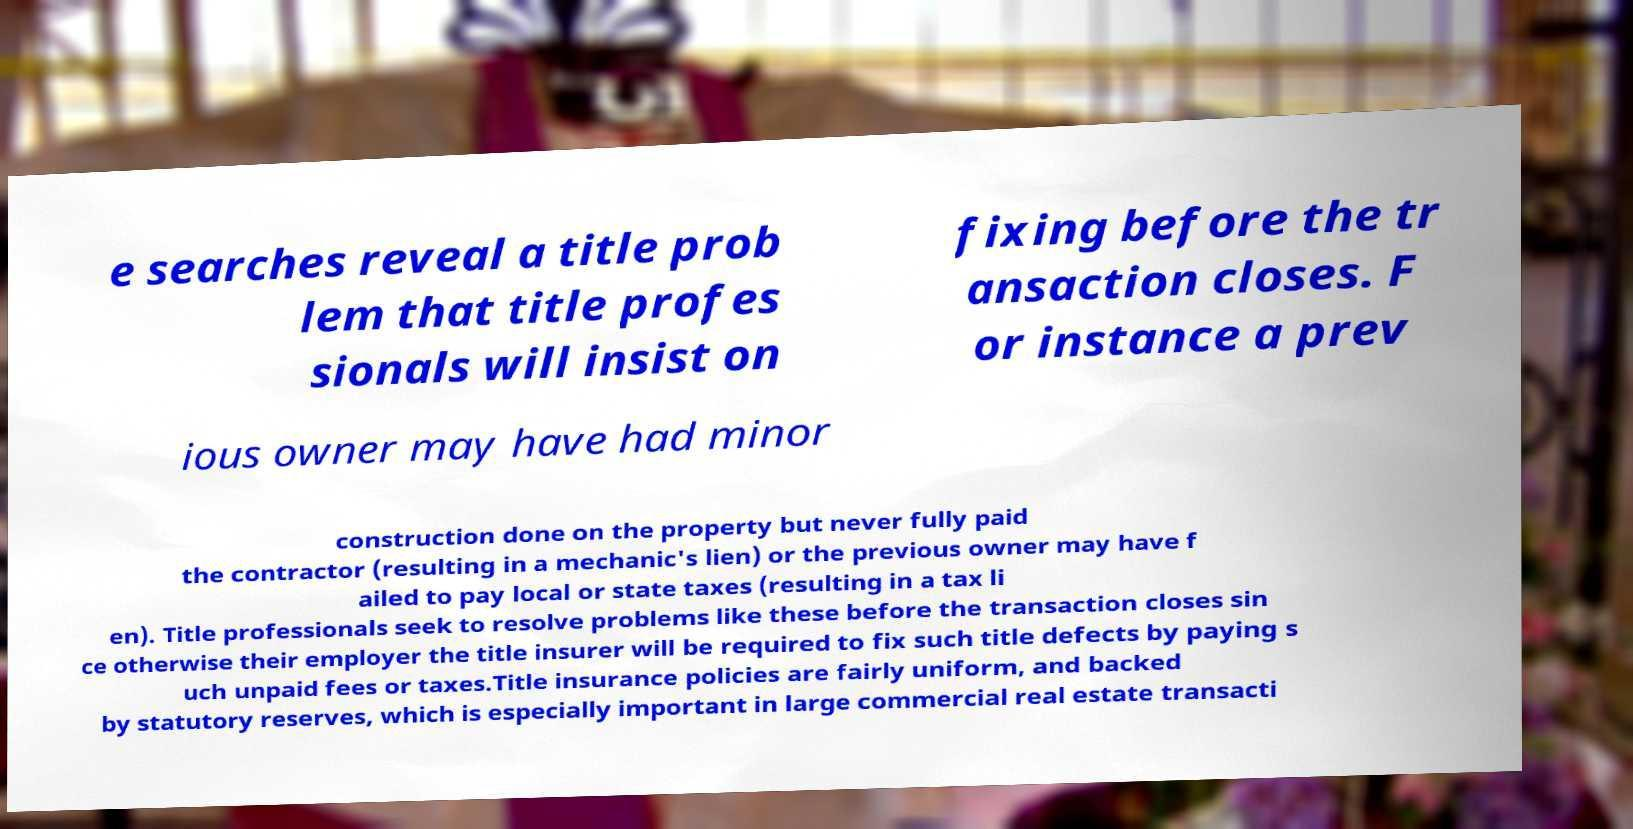There's text embedded in this image that I need extracted. Can you transcribe it verbatim? e searches reveal a title prob lem that title profes sionals will insist on fixing before the tr ansaction closes. F or instance a prev ious owner may have had minor construction done on the property but never fully paid the contractor (resulting in a mechanic's lien) or the previous owner may have f ailed to pay local or state taxes (resulting in a tax li en). Title professionals seek to resolve problems like these before the transaction closes sin ce otherwise their employer the title insurer will be required to fix such title defects by paying s uch unpaid fees or taxes.Title insurance policies are fairly uniform, and backed by statutory reserves, which is especially important in large commercial real estate transacti 